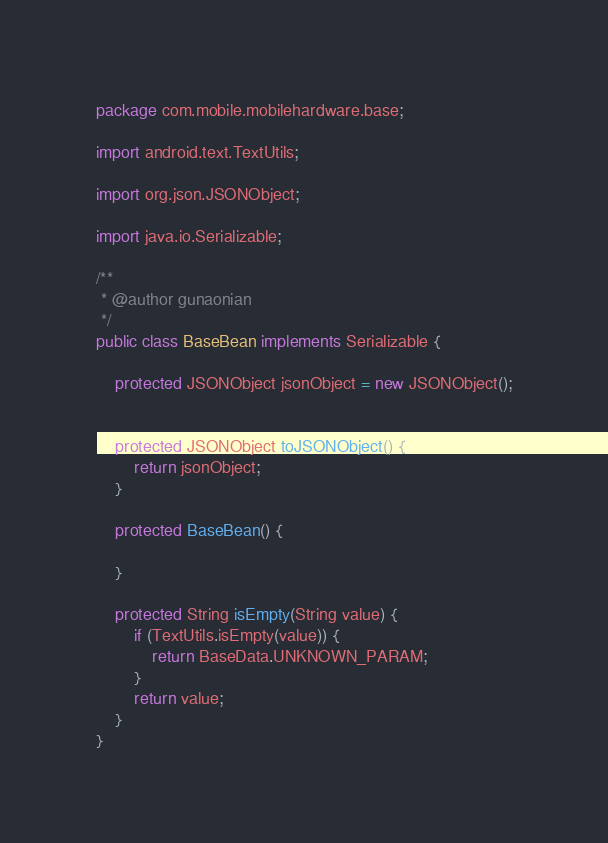Convert code to text. <code><loc_0><loc_0><loc_500><loc_500><_Java_>package com.mobile.mobilehardware.base;

import android.text.TextUtils;

import org.json.JSONObject;

import java.io.Serializable;

/**
 * @author gunaonian
 */
public class BaseBean implements Serializable {

    protected JSONObject jsonObject = new JSONObject();


    protected JSONObject toJSONObject() {
        return jsonObject;
    }

    protected BaseBean() {

    }

    protected String isEmpty(String value) {
        if (TextUtils.isEmpty(value)) {
            return BaseData.UNKNOWN_PARAM;
        }
        return value;
    }
}
</code> 